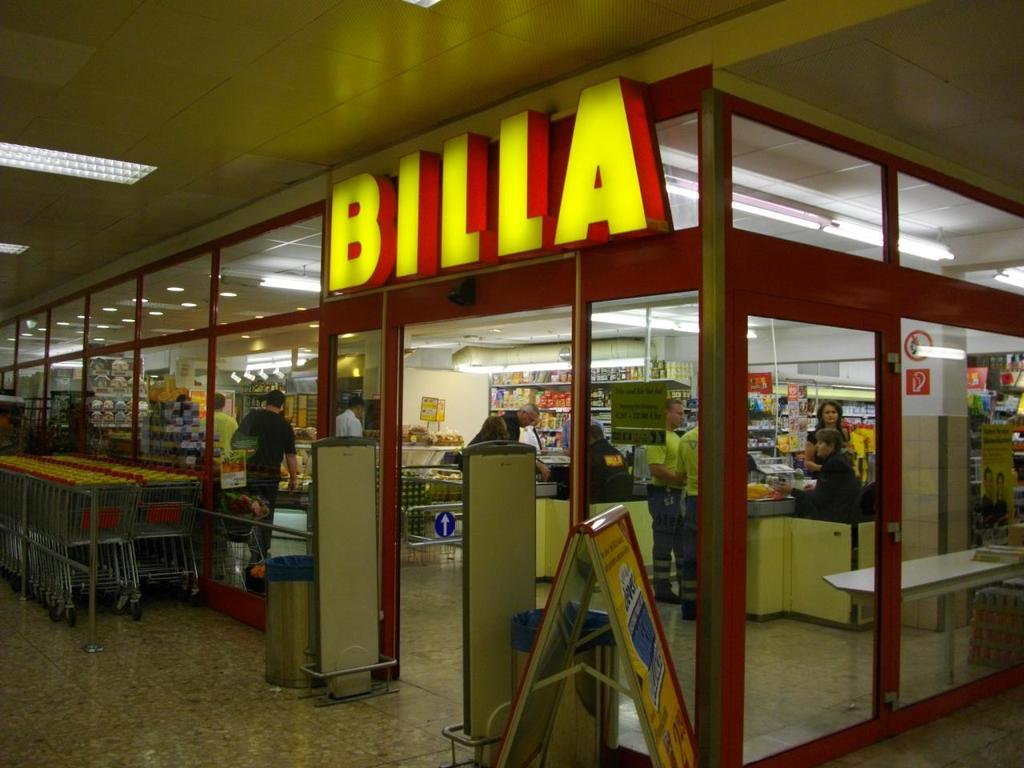<image>
Create a compact narrative representing the image presented. The store Billa is open and there are many grocery carts out front. 